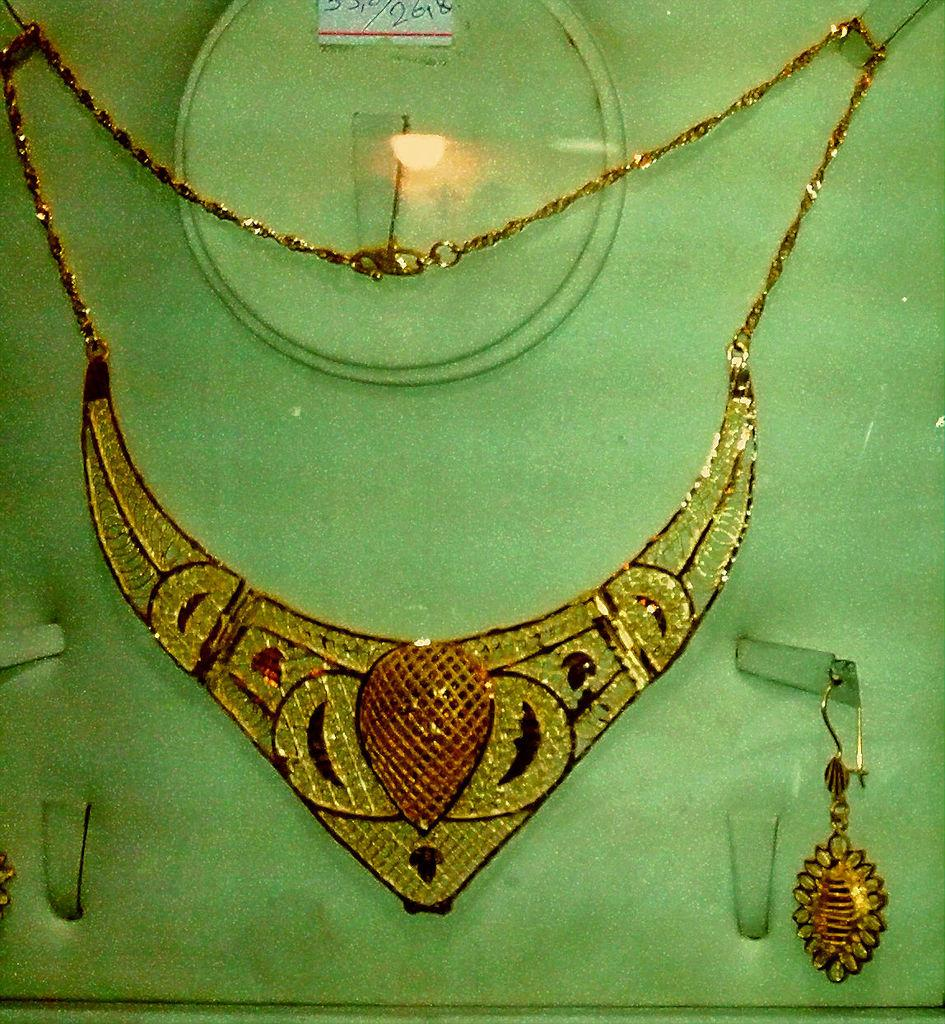What type of decorative items can be seen in the image? There are ornaments in the image. Can you describe any additional details about the ornaments? Unfortunately, the provided facts do not offer any additional details about the ornaments. What is the sticker attached to in the image? The facts do not specify what the sticker is attached to. How many eggs are present in the image? There is no mention of eggs in the provided facts, so we cannot determine their presence or quantity in the image. What type of nerve is visible in the image? There is no mention of nerves in the provided facts, so we cannot determine their presence or type in the image. 